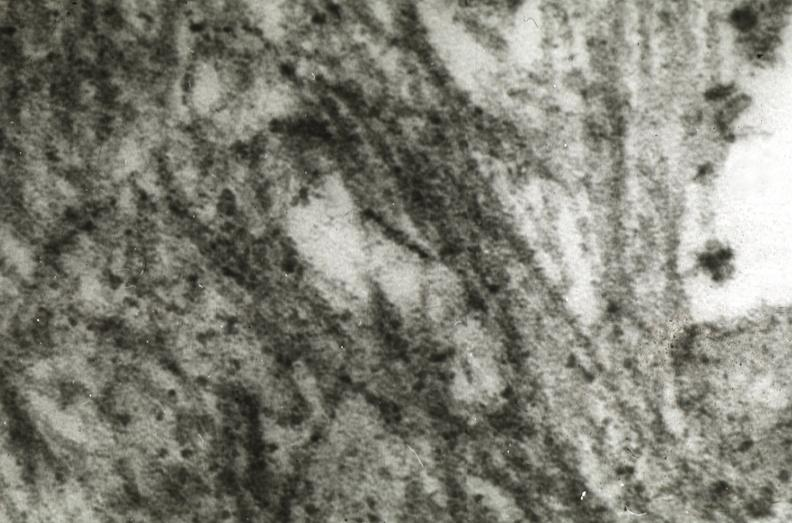does this image show amyloidosis?
Answer the question using a single word or phrase. Yes 